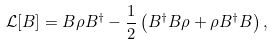Convert formula to latex. <formula><loc_0><loc_0><loc_500><loc_500>\mathcal { L } [ B ] = B \rho B ^ { \dagger } - \frac { 1 } { 2 } \left ( B ^ { \dagger } B \rho + \rho B ^ { \dagger } B \right ) ,</formula> 